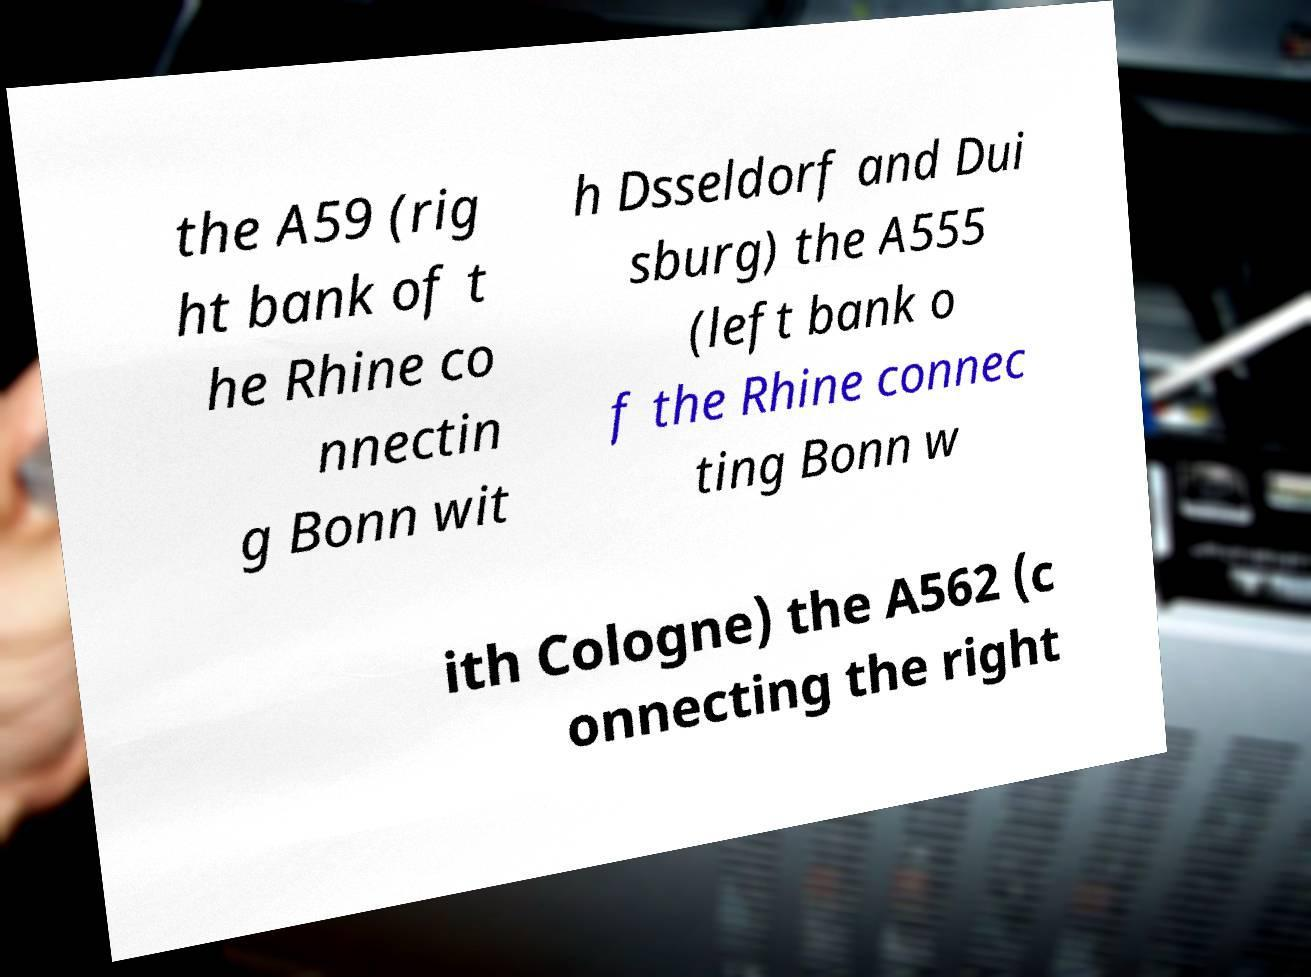Please identify and transcribe the text found in this image. the A59 (rig ht bank of t he Rhine co nnectin g Bonn wit h Dsseldorf and Dui sburg) the A555 (left bank o f the Rhine connec ting Bonn w ith Cologne) the A562 (c onnecting the right 